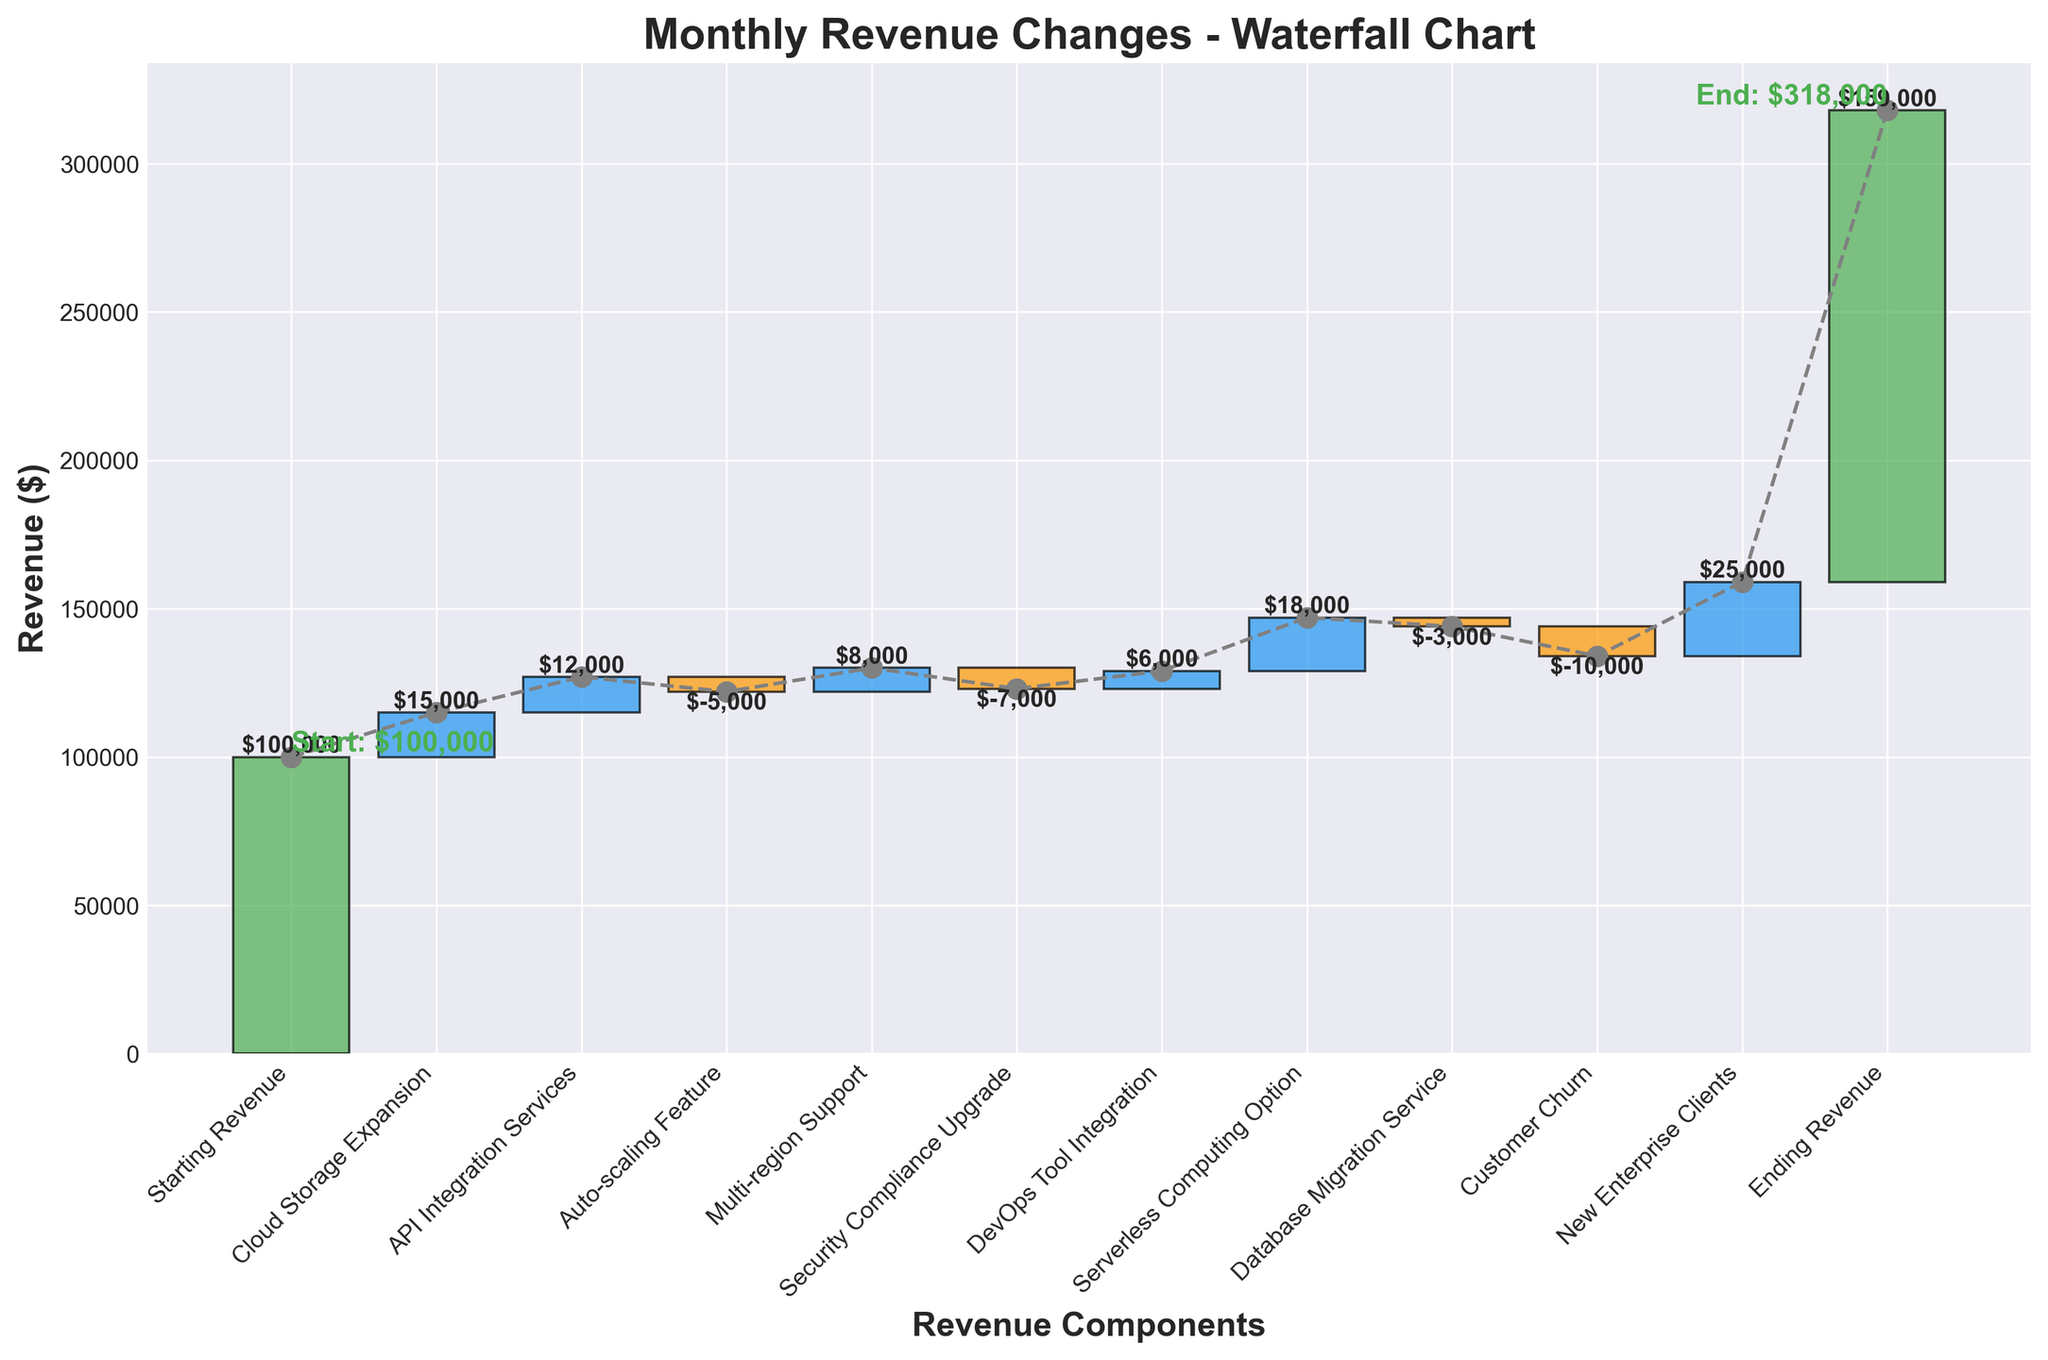What's the starting revenue? The first bar in the chart represents the starting revenue. It is labeled "Starting Revenue" and has a value of $100,000.
Answer: $100,000 What's the ending revenue? The last bar in the chart represents the ending revenue. It is labeled "Ending Revenue" and has a value of $159,000.
Answer: $159,000 Which feature caused the highest revenue increase? To determine the highest revenue increase, look at the positive values on the chart. The "New Enterprise Clients" bar shows a value of $25,000, which is the highest positive value.
Answer: New Enterprise Clients Which feature caused the highest revenue loss? To find the highest revenue loss, identify the negative value bars. The "Customer Churn" bar has a value of -$10,000, which is the highest negative value.
Answer: Customer Churn What’s the net change in revenue from "API Integration Services" and "Auto-scaling Feature"? Add the positive change from "API Integration Services" ($12,000) and the negative change from "Auto-scaling Feature" (-$5,000). The net change is $12,000 - $5,000 = $7,000.
Answer: $7,000 Compare the revenue impact of "Serverless Computing Option" and "Database Migration Service". Which feature had a greater impact? The "Serverless Computing Option" added $18,000. The "Database Migration Service" reduced revenue by $3,000. The impact of "Serverless Computing Option" ($18,000) is greater than the impact of "Database Migration Service" ($-3,000).
Answer: Serverless Computing Option How many features contributed to revenue gains? Count the positive bars after the "Starting Revenue". These are: "Cloud Storage Expansion", "API Integration Services", "Multi-region Support", "DevOps Tool Integration", "Serverless Computing Option", and "New Enterprise Clients", totaling 6 features.
Answer: 6 What's the total revenue gained from all positive contributions? Sum up all positive values: 15000 (Cloud Storage Expansion) + 12000 (API Integration Services) + 8000 (Multi-region Support) + 6000 (DevOps Tool Integration) + 18000 (Serverless Computing Option) + 25000 (New Enterprise Clients) = 84,000.
Answer: $84,000 What's the cumulative revenue before the "Customer Churn"? Start with the initial revenue of $100,000 and add up the changes up to and including "Database Migration Service": 100,000 (Starting Revenue) + 15,000 (Cloud Storage Expansion) + 12,000 (API Integration Services) - 5,000 (Auto-scaling Feature) + 8,000 (Multi-region Support) - 7,000 (Security Compliance Upgrade) + 6,000 (DevOps Tool Integration) + 18,000 (Serverless Computing Option) - 3,000 (Database Migration Service) = 144,000.
Answer: $144,000 